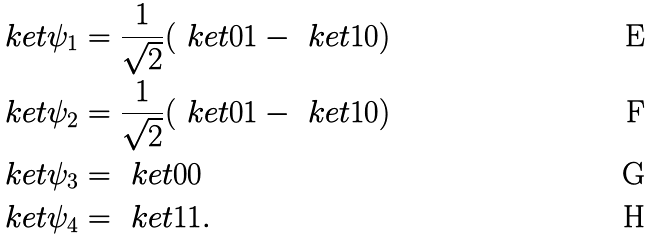Convert formula to latex. <formula><loc_0><loc_0><loc_500><loc_500>\ k e t { \psi _ { 1 } } & = \frac { 1 } { \sqrt { 2 } } ( \ k e t { 0 1 } - \ k e t { 1 0 } ) \\ \ k e t { \psi _ { 2 } } & = \frac { 1 } { \sqrt { 2 } } ( \ k e t { 0 1 } - \ k e t { 1 0 } ) \\ \ k e t { \psi _ { 3 } } & = \ k e t { 0 0 } \\ \ k e t { \psi _ { 4 } } & = \ k e t { 1 1 } .</formula> 